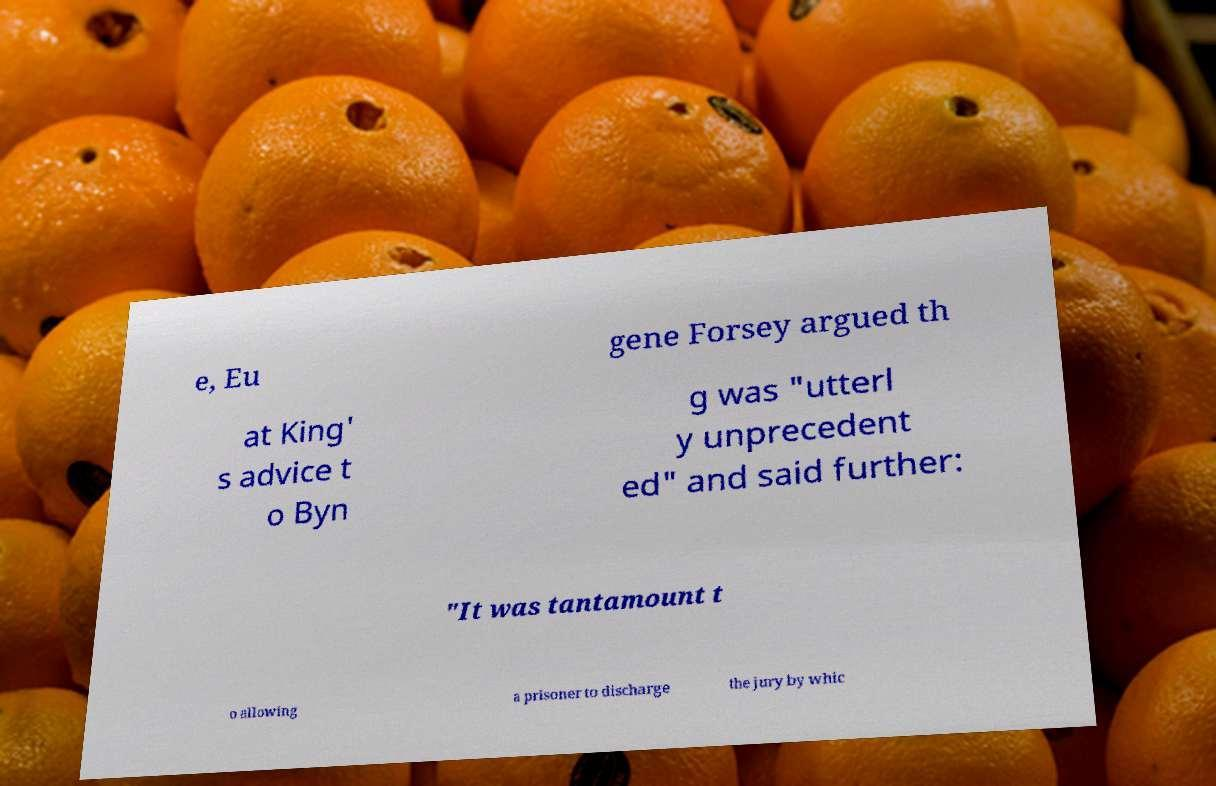I need the written content from this picture converted into text. Can you do that? e, Eu gene Forsey argued th at King' s advice t o Byn g was "utterl y unprecedent ed" and said further: "It was tantamount t o allowing a prisoner to discharge the jury by whic 